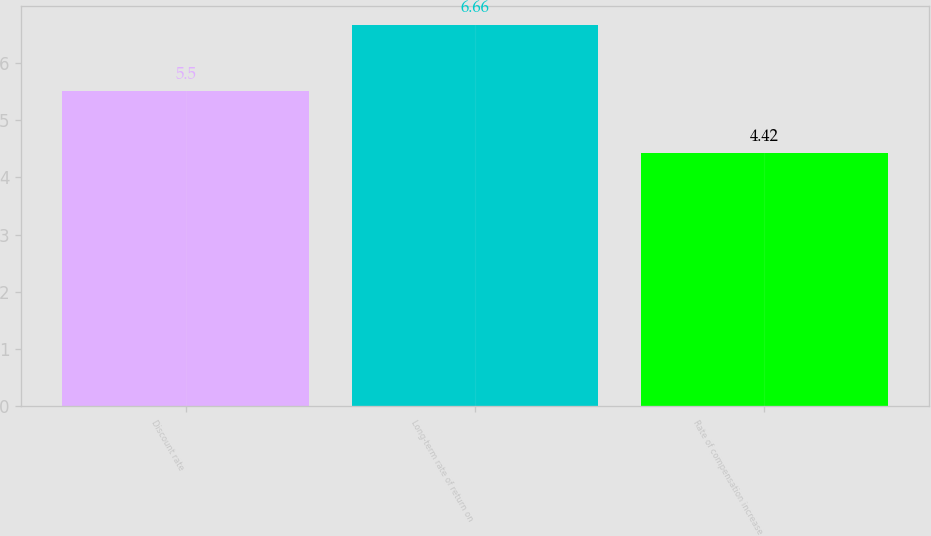Convert chart. <chart><loc_0><loc_0><loc_500><loc_500><bar_chart><fcel>Discount rate<fcel>Long-term rate of return on<fcel>Rate of compensation increase<nl><fcel>5.5<fcel>6.66<fcel>4.42<nl></chart> 